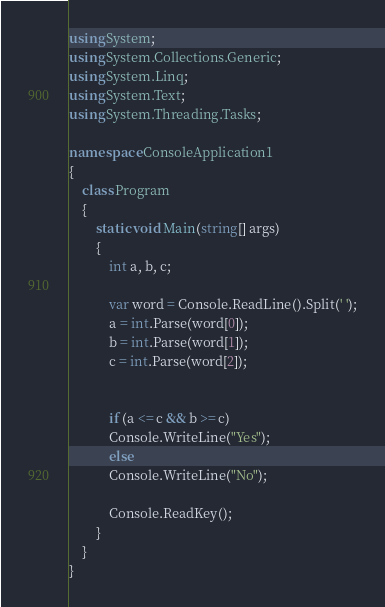<code> <loc_0><loc_0><loc_500><loc_500><_C#_>using System;
using System.Collections.Generic;
using System.Linq;
using System.Text;
using System.Threading.Tasks;

namespace ConsoleApplication1
{
    class Program
    {
        static void Main(string[] args)
        {
            int a, b, c;

            var word = Console.ReadLine().Split(' ');
            a = int.Parse(word[0]);
            b = int.Parse(word[1]);
            c = int.Parse(word[2]);


            if (a <= c && b >= c)
            Console.WriteLine("Yes");
            else
            Console.WriteLine("No");

            Console.ReadKey();
        }
    }
}
</code> 